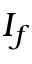Convert formula to latex. <formula><loc_0><loc_0><loc_500><loc_500>I _ { f }</formula> 